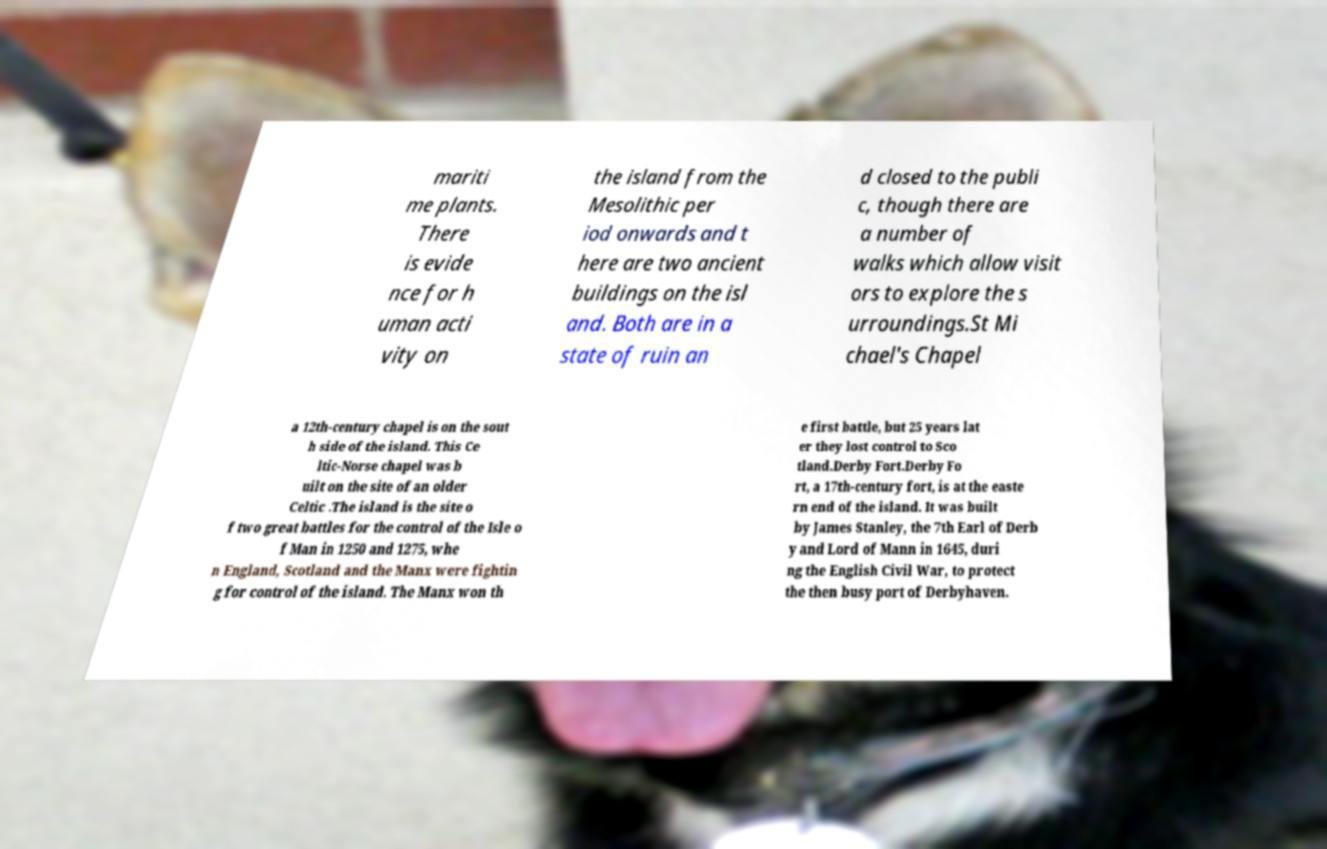Can you read and provide the text displayed in the image?This photo seems to have some interesting text. Can you extract and type it out for me? mariti me plants. There is evide nce for h uman acti vity on the island from the Mesolithic per iod onwards and t here are two ancient buildings on the isl and. Both are in a state of ruin an d closed to the publi c, though there are a number of walks which allow visit ors to explore the s urroundings.St Mi chael's Chapel a 12th-century chapel is on the sout h side of the island. This Ce ltic-Norse chapel was b uilt on the site of an older Celtic .The island is the site o f two great battles for the control of the Isle o f Man in 1250 and 1275, whe n England, Scotland and the Manx were fightin g for control of the island. The Manx won th e first battle, but 25 years lat er they lost control to Sco tland.Derby Fort.Derby Fo rt, a 17th-century fort, is at the easte rn end of the island. It was built by James Stanley, the 7th Earl of Derb y and Lord of Mann in 1645, duri ng the English Civil War, to protect the then busy port of Derbyhaven. 